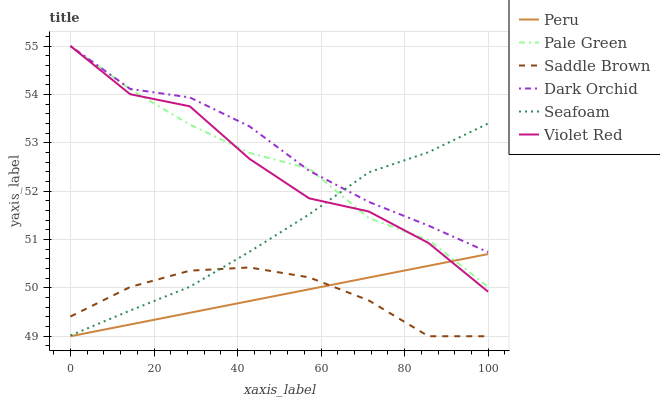Does Peru have the minimum area under the curve?
Answer yes or no. Yes. Does Dark Orchid have the maximum area under the curve?
Answer yes or no. Yes. Does Seafoam have the minimum area under the curve?
Answer yes or no. No. Does Seafoam have the maximum area under the curve?
Answer yes or no. No. Is Peru the smoothest?
Answer yes or no. Yes. Is Violet Red the roughest?
Answer yes or no. Yes. Is Seafoam the smoothest?
Answer yes or no. No. Is Seafoam the roughest?
Answer yes or no. No. Does Peru have the lowest value?
Answer yes or no. Yes. Does Seafoam have the lowest value?
Answer yes or no. No. Does Pale Green have the highest value?
Answer yes or no. Yes. Does Seafoam have the highest value?
Answer yes or no. No. Is Saddle Brown less than Pale Green?
Answer yes or no. Yes. Is Seafoam greater than Peru?
Answer yes or no. Yes. Does Violet Red intersect Pale Green?
Answer yes or no. Yes. Is Violet Red less than Pale Green?
Answer yes or no. No. Is Violet Red greater than Pale Green?
Answer yes or no. No. Does Saddle Brown intersect Pale Green?
Answer yes or no. No. 